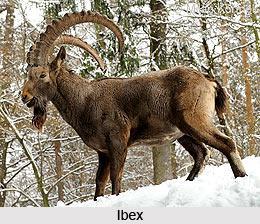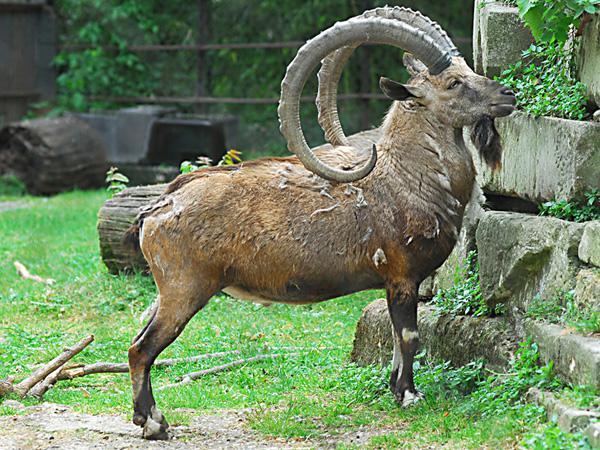The first image is the image on the left, the second image is the image on the right. For the images shown, is this caption "In 1 of the images, 1 of the goats is seated." true? Answer yes or no. No. The first image is the image on the left, the second image is the image on the right. Given the left and right images, does the statement "Left image shows a horned animal standing on non-grassy surface with body and head in profile turned leftward." hold true? Answer yes or no. Yes. 